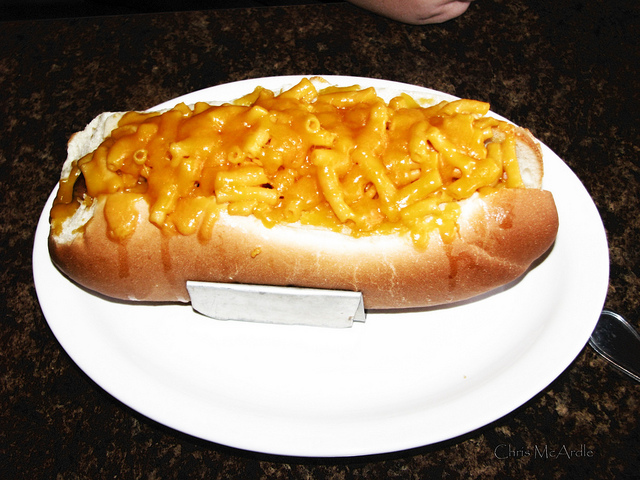<image>Where is the sauerkraut? I don't know where the sauerkraut is. It can be under macaroni and cheese or on the bread. Where is the sauerkraut? It is unclear where the sauerkraut is located. It could be under the macaroni and cheese, under the cheese, or on the bread. 